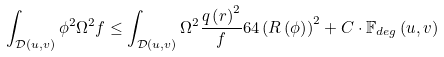Convert formula to latex. <formula><loc_0><loc_0><loc_500><loc_500>\int _ { \mathcal { D } \left ( u , v \right ) } \phi ^ { 2 } \Omega ^ { 2 } f \leq \int _ { \mathcal { D } \left ( u , v \right ) } \Omega ^ { 2 } \frac { q \left ( r \right ) ^ { 2 } } { f } 6 4 \left ( R \left ( \phi \right ) \right ) ^ { 2 } + C \cdot \mathbb { F } _ { d e g } \left ( u , v \right )</formula> 